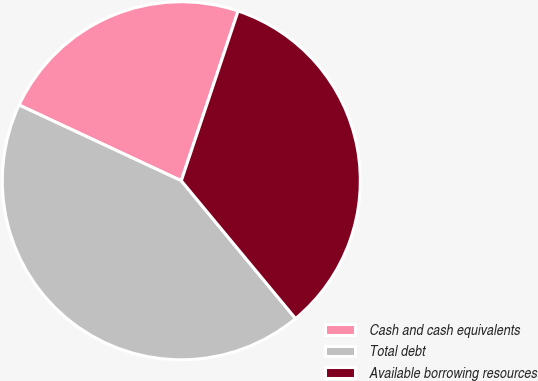<chart> <loc_0><loc_0><loc_500><loc_500><pie_chart><fcel>Cash and cash equivalents<fcel>Total debt<fcel>Available borrowing resources<nl><fcel>23.19%<fcel>42.97%<fcel>33.84%<nl></chart> 